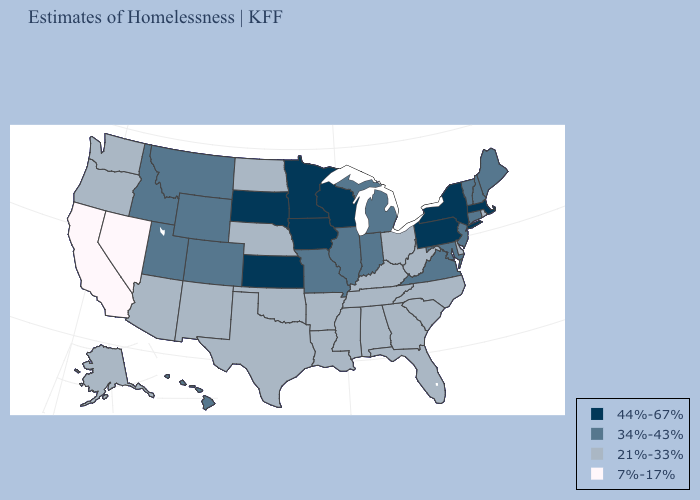Name the states that have a value in the range 7%-17%?
Write a very short answer. California, Nevada. What is the lowest value in the South?
Answer briefly. 21%-33%. What is the value of Indiana?
Concise answer only. 34%-43%. What is the highest value in states that border Georgia?
Give a very brief answer. 21%-33%. Does Pennsylvania have a higher value than Minnesota?
Write a very short answer. No. What is the value of New Hampshire?
Concise answer only. 34%-43%. Does Wisconsin have the highest value in the USA?
Write a very short answer. Yes. What is the value of Michigan?
Quick response, please. 34%-43%. What is the value of New York?
Be succinct. 44%-67%. Does Wisconsin have the same value as Kansas?
Short answer required. Yes. Does Maryland have the highest value in the South?
Keep it brief. Yes. Which states have the lowest value in the USA?
Write a very short answer. California, Nevada. Among the states that border New Hampshire , does Massachusetts have the lowest value?
Answer briefly. No. What is the lowest value in the USA?
Quick response, please. 7%-17%. 